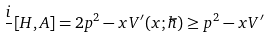<formula> <loc_0><loc_0><loc_500><loc_500>\frac { i } { } [ H , A ] = 2 p ^ { 2 } - x V ^ { \prime } ( x ; \hbar { ) } \geq p ^ { 2 } - x V ^ { \prime }</formula> 